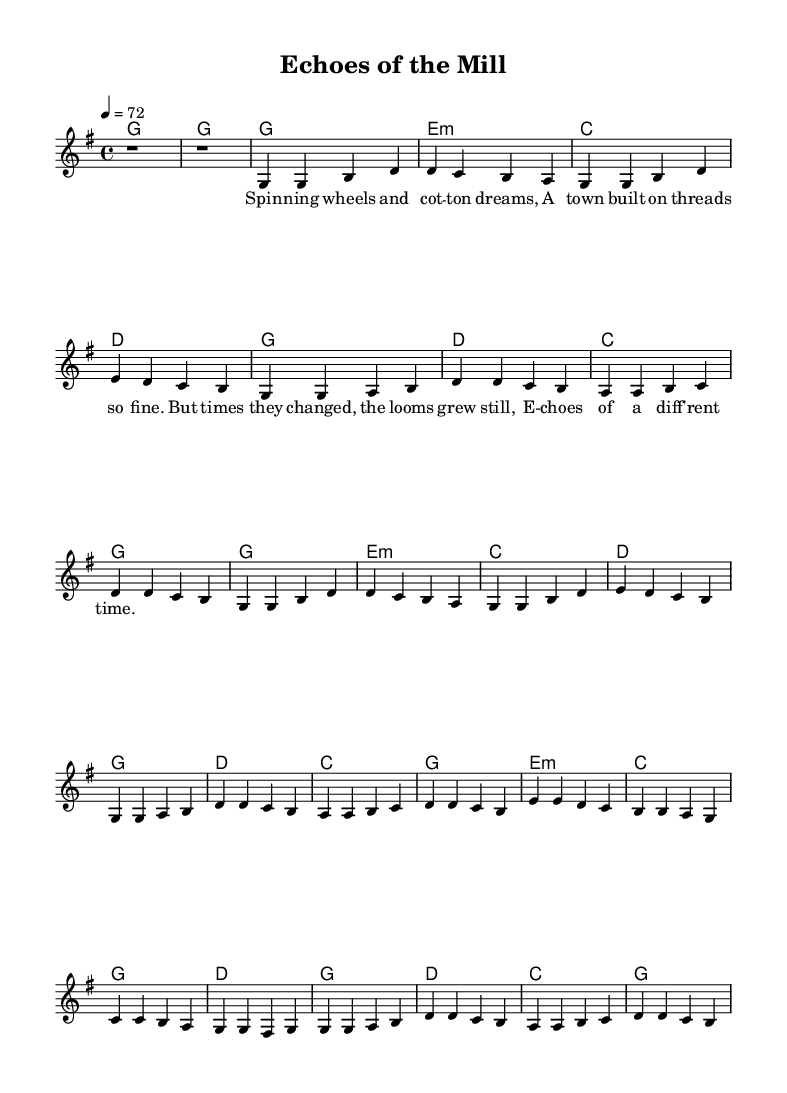What is the key signature of this music? The key signature indicated in the music is G major, which has one sharp (F#). This can be identified in the key signature section of the sheet music.
Answer: G major What is the time signature of the piece? The time signature marked in the music is 4/4, which means there are four beats in each measure and the quarter note gets one beat. This is specified at the beginning of the score.
Answer: 4/4 What is the tempo marking for this music? The tempo marking is indicated as 72 beats per minute, noted as "4 = 72" at the beginning of the music. This indicates the speed at which the piece should be played.
Answer: 72 How many verses are there in the song structure? The song structure shows there are two verses as indicated in the repeated sections of the melody and lyrics. Each verse is structured similarly, making it easy to count.
Answer: 2 What type of harmonies are used in the bridge section? The bridge section contains minor and major harmonies, specifically an e minor chord followed by c major, g major, and d major chords. This can be deduced from the chord symbols notated in the harmonies section.
Answer: Minor and major What is the main theme of the lyrics in the song? The main theme revolves around the historical aspect of a town with its spinning wheels and cotton dreams, reflecting on changes over time. This can be understood from the lines presented in the lyric section.
Answer: Historical change How is the chorus musically different from the verses? The chorus has a different melodic contour and is often more emotionally impactful compared to the verses, which is common in pop ballads. This can be determined by observing the rise in melody and the relevant chord progression in the score.
Answer: More impactful melodies 